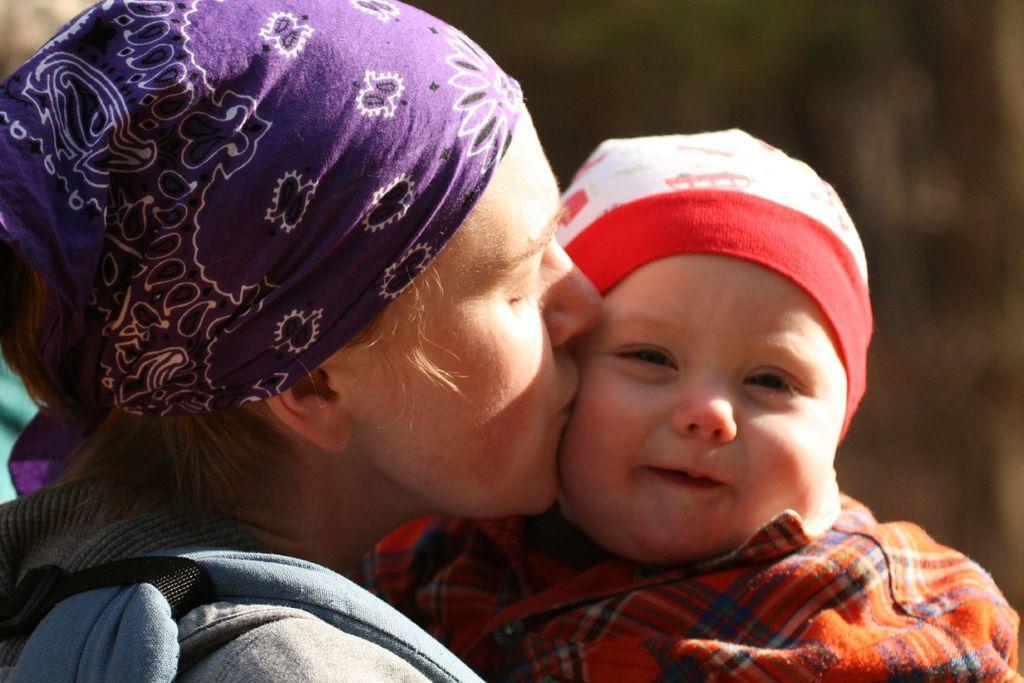How would you summarize this image in a sentence or two? In this image I can see a person kissing a baby. The baby is smiling. The background is blurred. 